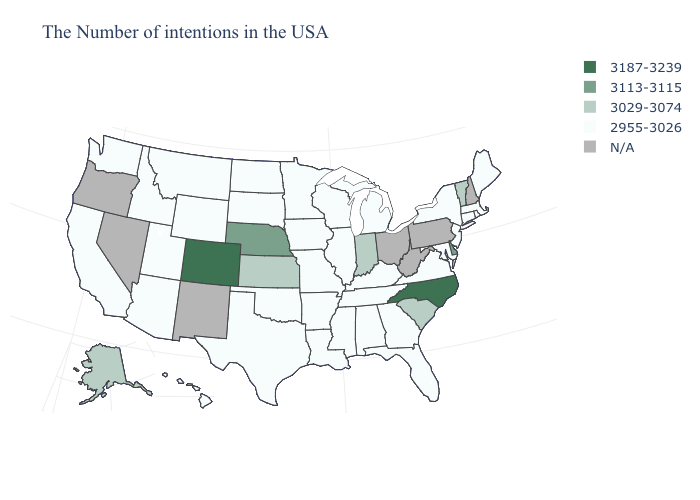Which states hav the highest value in the West?
Concise answer only. Colorado. Does Alaska have the highest value in the USA?
Answer briefly. No. What is the value of South Dakota?
Quick response, please. 2955-3026. What is the value of Louisiana?
Short answer required. 2955-3026. Name the states that have a value in the range 2955-3026?
Answer briefly. Maine, Massachusetts, Rhode Island, Connecticut, New York, New Jersey, Maryland, Virginia, Florida, Georgia, Michigan, Kentucky, Alabama, Tennessee, Wisconsin, Illinois, Mississippi, Louisiana, Missouri, Arkansas, Minnesota, Iowa, Oklahoma, Texas, South Dakota, North Dakota, Wyoming, Utah, Montana, Arizona, Idaho, California, Washington, Hawaii. Name the states that have a value in the range 3187-3239?
Be succinct. North Carolina, Colorado. What is the value of Minnesota?
Short answer required. 2955-3026. Which states have the lowest value in the West?
Quick response, please. Wyoming, Utah, Montana, Arizona, Idaho, California, Washington, Hawaii. Does Alaska have the highest value in the USA?
Concise answer only. No. What is the highest value in the West ?
Answer briefly. 3187-3239. What is the value of Michigan?
Give a very brief answer. 2955-3026. What is the highest value in the South ?
Write a very short answer. 3187-3239. Does the map have missing data?
Keep it brief. Yes. 